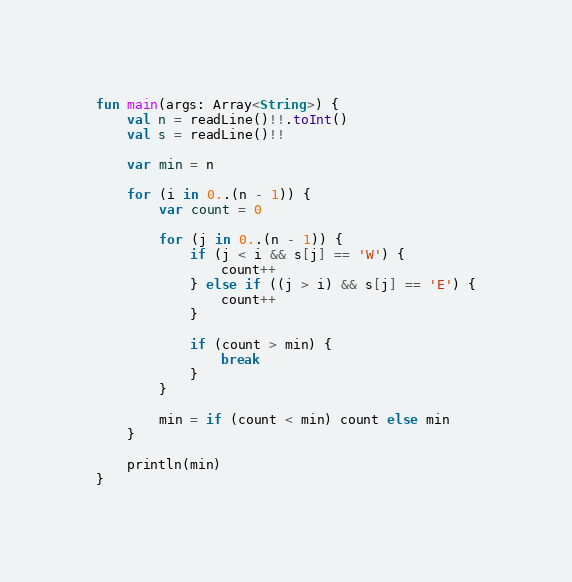Convert code to text. <code><loc_0><loc_0><loc_500><loc_500><_Kotlin_>fun main(args: Array<String>) {
    val n = readLine()!!.toInt()
    val s = readLine()!!

    var min = n

    for (i in 0..(n - 1)) {
        var count = 0

        for (j in 0..(n - 1)) {
            if (j < i && s[j] == 'W') {
                count++
            } else if ((j > i) && s[j] == 'E') {
                count++
            }

            if (count > min) {
                break
            }
        }

        min = if (count < min) count else min
    }

    println(min)
}
</code> 